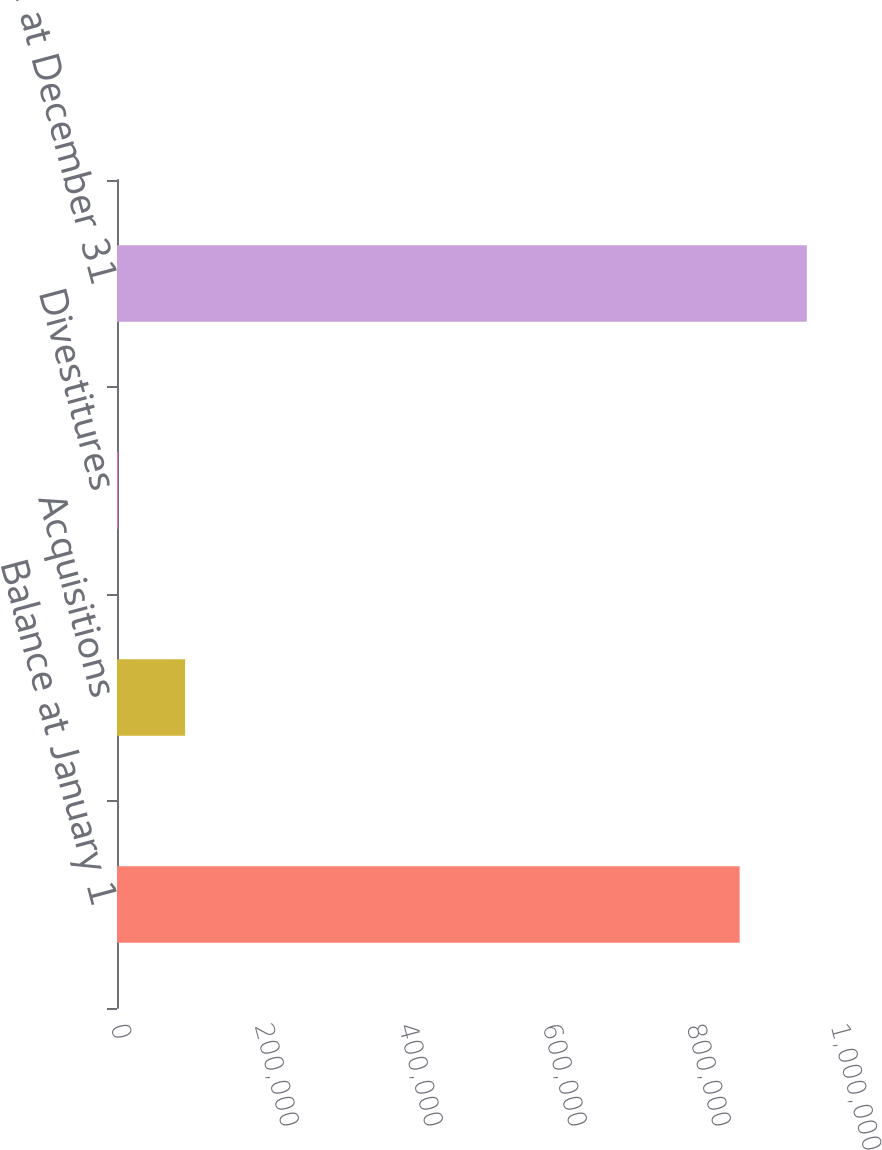Convert chart. <chart><loc_0><loc_0><loc_500><loc_500><bar_chart><fcel>Balance at January 1<fcel>Acquisitions<fcel>Divestitures<fcel>Balance at December 31<nl><fcel>864786<fcel>94587<fcel>1298<fcel>958075<nl></chart> 